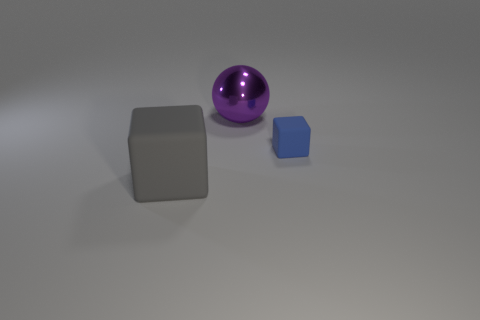What might be the purpose of this arrangement of objects? This arrangement of objects could be an intentional setup for an artistic composition, a 3D modeling test, or a visual demonstration of size and perspective. 